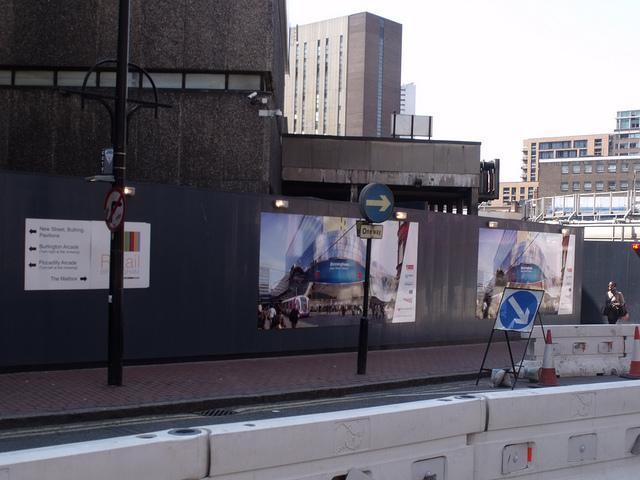What are the blue signs being used for? directions 